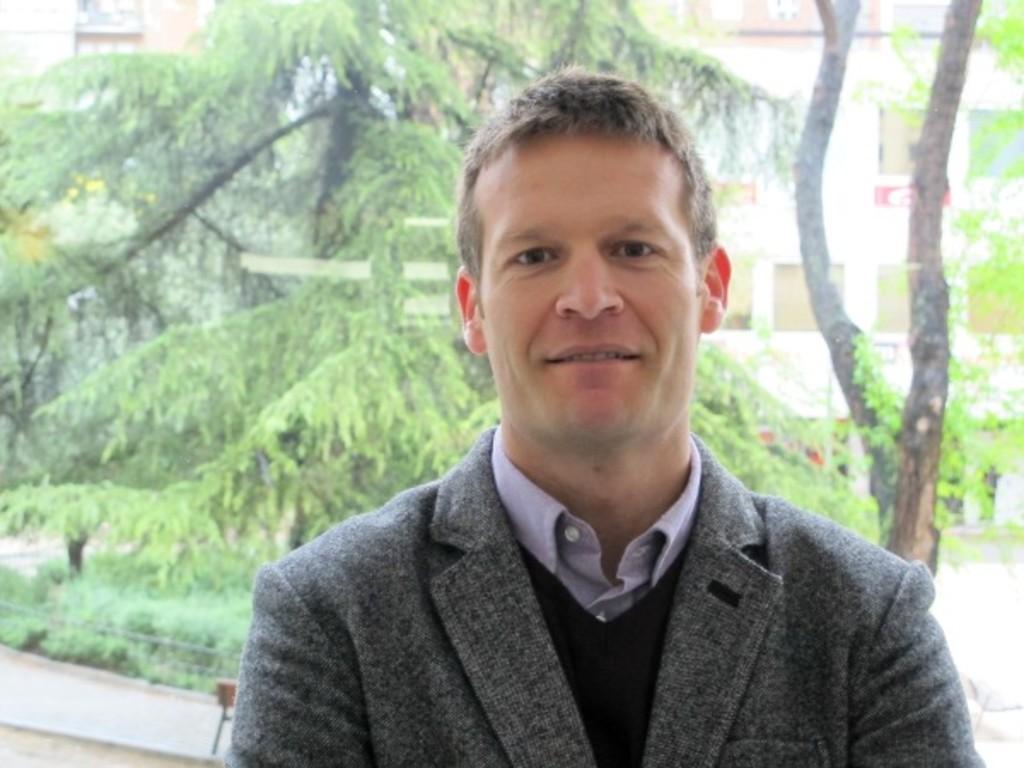Describe this image in one or two sentences. In this image there is a man in the middle who is wearing the ash color jacket. In the background there are trees on the left side and a building on the right side. 